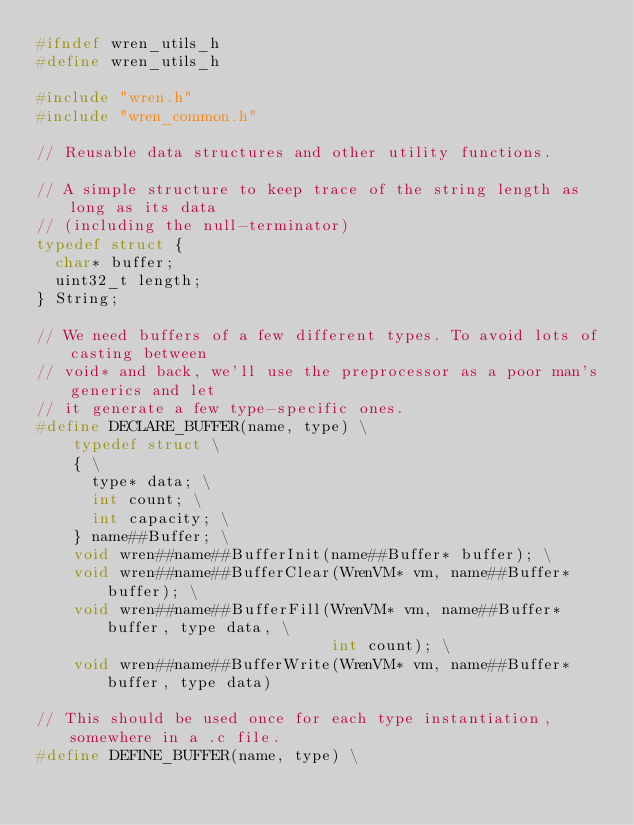Convert code to text. <code><loc_0><loc_0><loc_500><loc_500><_C_>#ifndef wren_utils_h
#define wren_utils_h

#include "wren.h"
#include "wren_common.h"

// Reusable data structures and other utility functions.

// A simple structure to keep trace of the string length as long as its data
// (including the null-terminator)
typedef struct {
  char* buffer;
  uint32_t length;
} String;

// We need buffers of a few different types. To avoid lots of casting between
// void* and back, we'll use the preprocessor as a poor man's generics and let
// it generate a few type-specific ones.
#define DECLARE_BUFFER(name, type) \
    typedef struct \
    { \
      type* data; \
      int count; \
      int capacity; \
    } name##Buffer; \
    void wren##name##BufferInit(name##Buffer* buffer); \
    void wren##name##BufferClear(WrenVM* vm, name##Buffer* buffer); \
    void wren##name##BufferFill(WrenVM* vm, name##Buffer* buffer, type data, \
                                int count); \
    void wren##name##BufferWrite(WrenVM* vm, name##Buffer* buffer, type data)

// This should be used once for each type instantiation, somewhere in a .c file.
#define DEFINE_BUFFER(name, type) \</code> 